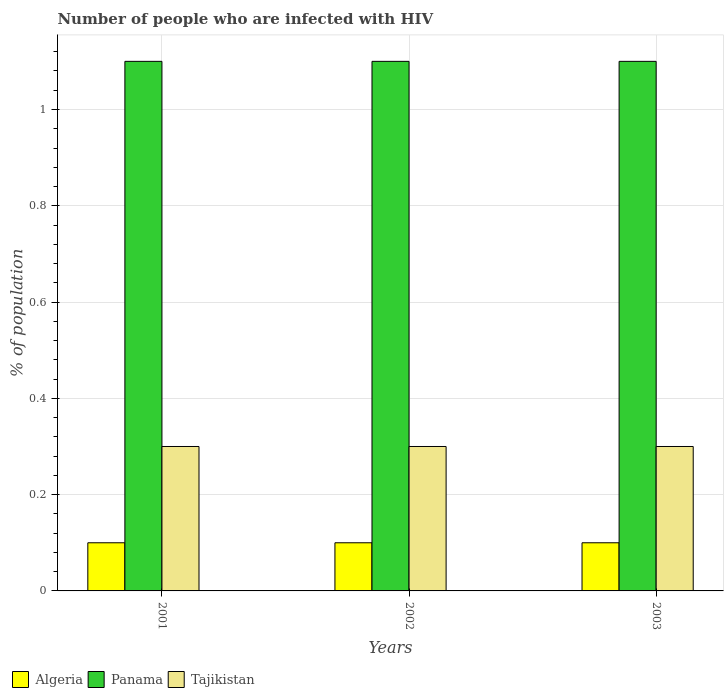How many different coloured bars are there?
Give a very brief answer. 3. How many bars are there on the 1st tick from the left?
Your answer should be compact. 3. How many bars are there on the 3rd tick from the right?
Offer a very short reply. 3. In how many cases, is the number of bars for a given year not equal to the number of legend labels?
Provide a short and direct response. 0. What is the total percentage of HIV infected population in in Panama in the graph?
Offer a very short reply. 3.3. What is the difference between the percentage of HIV infected population in in Panama in 2001 and that in 2002?
Your answer should be compact. 0. What is the difference between the percentage of HIV infected population in in Tajikistan in 2003 and the percentage of HIV infected population in in Algeria in 2002?
Keep it short and to the point. 0.2. What is the average percentage of HIV infected population in in Algeria per year?
Offer a terse response. 0.1. In the year 2002, what is the difference between the percentage of HIV infected population in in Tajikistan and percentage of HIV infected population in in Algeria?
Keep it short and to the point. 0.2. Is the sum of the percentage of HIV infected population in in Tajikistan in 2001 and 2002 greater than the maximum percentage of HIV infected population in in Panama across all years?
Ensure brevity in your answer.  No. What does the 2nd bar from the left in 2001 represents?
Provide a succinct answer. Panama. What does the 2nd bar from the right in 2002 represents?
Offer a terse response. Panama. Is it the case that in every year, the sum of the percentage of HIV infected population in in Tajikistan and percentage of HIV infected population in in Algeria is greater than the percentage of HIV infected population in in Panama?
Give a very brief answer. No. How many bars are there?
Offer a terse response. 9. Does the graph contain any zero values?
Offer a terse response. No. Does the graph contain grids?
Your response must be concise. Yes. Where does the legend appear in the graph?
Your answer should be compact. Bottom left. How many legend labels are there?
Your response must be concise. 3. What is the title of the graph?
Keep it short and to the point. Number of people who are infected with HIV. What is the label or title of the Y-axis?
Your answer should be very brief. % of population. What is the % of population of Algeria in 2001?
Keep it short and to the point. 0.1. What is the % of population in Tajikistan in 2001?
Provide a short and direct response. 0.3. What is the % of population of Algeria in 2002?
Keep it short and to the point. 0.1. What is the % of population in Panama in 2002?
Keep it short and to the point. 1.1. What is the % of population in Tajikistan in 2002?
Offer a very short reply. 0.3. What is the % of population of Algeria in 2003?
Your answer should be very brief. 0.1. Across all years, what is the maximum % of population of Algeria?
Make the answer very short. 0.1. Across all years, what is the maximum % of population of Panama?
Provide a succinct answer. 1.1. Across all years, what is the maximum % of population in Tajikistan?
Keep it short and to the point. 0.3. Across all years, what is the minimum % of population in Algeria?
Offer a very short reply. 0.1. Across all years, what is the minimum % of population in Panama?
Provide a short and direct response. 1.1. What is the difference between the % of population of Algeria in 2001 and that in 2002?
Offer a terse response. 0. What is the difference between the % of population in Panama in 2001 and that in 2002?
Your answer should be very brief. 0. What is the difference between the % of population of Tajikistan in 2001 and that in 2002?
Ensure brevity in your answer.  0. What is the difference between the % of population of Algeria in 2002 and that in 2003?
Your answer should be very brief. 0. What is the difference between the % of population of Panama in 2002 and that in 2003?
Your answer should be compact. 0. What is the difference between the % of population in Algeria in 2001 and the % of population in Panama in 2002?
Provide a succinct answer. -1. What is the difference between the % of population of Algeria in 2001 and the % of population of Panama in 2003?
Your answer should be compact. -1. What is the difference between the % of population in Panama in 2001 and the % of population in Tajikistan in 2003?
Offer a very short reply. 0.8. What is the difference between the % of population in Algeria in 2002 and the % of population in Panama in 2003?
Your answer should be very brief. -1. What is the average % of population of Panama per year?
Offer a terse response. 1.1. What is the average % of population in Tajikistan per year?
Provide a succinct answer. 0.3. In the year 2001, what is the difference between the % of population in Algeria and % of population in Tajikistan?
Provide a succinct answer. -0.2. In the year 2002, what is the difference between the % of population in Algeria and % of population in Panama?
Make the answer very short. -1. In the year 2002, what is the difference between the % of population in Algeria and % of population in Tajikistan?
Your response must be concise. -0.2. In the year 2003, what is the difference between the % of population of Algeria and % of population of Tajikistan?
Offer a very short reply. -0.2. In the year 2003, what is the difference between the % of population of Panama and % of population of Tajikistan?
Offer a very short reply. 0.8. What is the ratio of the % of population of Panama in 2001 to that in 2002?
Offer a terse response. 1. What is the ratio of the % of population in Algeria in 2001 to that in 2003?
Your response must be concise. 1. What is the ratio of the % of population in Panama in 2001 to that in 2003?
Keep it short and to the point. 1. What is the ratio of the % of population in Algeria in 2002 to that in 2003?
Provide a succinct answer. 1. What is the ratio of the % of population of Panama in 2002 to that in 2003?
Ensure brevity in your answer.  1. What is the difference between the highest and the second highest % of population in Algeria?
Keep it short and to the point. 0. What is the difference between the highest and the second highest % of population in Panama?
Keep it short and to the point. 0. What is the difference between the highest and the lowest % of population in Panama?
Keep it short and to the point. 0. 